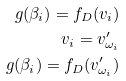<formula> <loc_0><loc_0><loc_500><loc_500>g ( \beta _ { i } ) = f _ { D } ( v _ { i } ) \\ v _ { i } = v ^ { \prime } _ { \omega _ { i } } \\ g ( \beta _ { i } ) = f _ { D } ( v ^ { \prime } _ { \omega _ { i } } )</formula> 